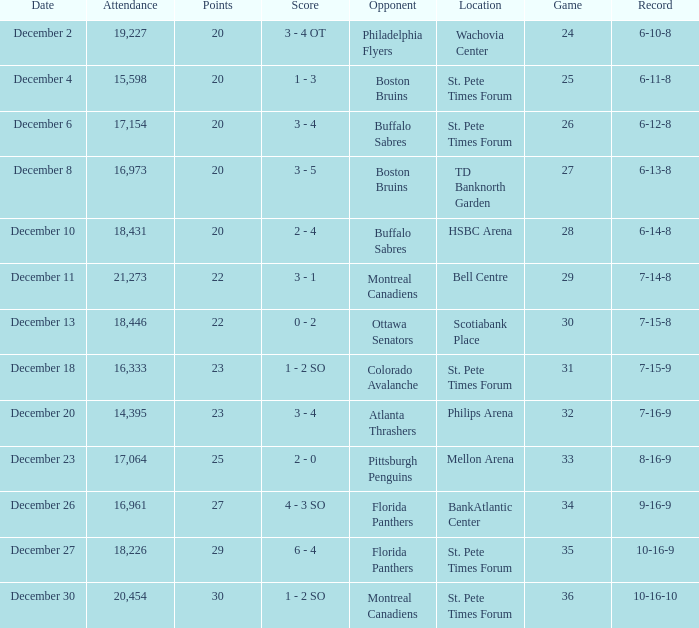Write the full table. {'header': ['Date', 'Attendance', 'Points', 'Score', 'Opponent', 'Location', 'Game', 'Record'], 'rows': [['December 2', '19,227', '20', '3 - 4 OT', 'Philadelphia Flyers', 'Wachovia Center', '24', '6-10-8'], ['December 4', '15,598', '20', '1 - 3', 'Boston Bruins', 'St. Pete Times Forum', '25', '6-11-8'], ['December 6', '17,154', '20', '3 - 4', 'Buffalo Sabres', 'St. Pete Times Forum', '26', '6-12-8'], ['December 8', '16,973', '20', '3 - 5', 'Boston Bruins', 'TD Banknorth Garden', '27', '6-13-8'], ['December 10', '18,431', '20', '2 - 4', 'Buffalo Sabres', 'HSBC Arena', '28', '6-14-8'], ['December 11', '21,273', '22', '3 - 1', 'Montreal Canadiens', 'Bell Centre', '29', '7-14-8'], ['December 13', '18,446', '22', '0 - 2', 'Ottawa Senators', 'Scotiabank Place', '30', '7-15-8'], ['December 18', '16,333', '23', '1 - 2 SO', 'Colorado Avalanche', 'St. Pete Times Forum', '31', '7-15-9'], ['December 20', '14,395', '23', '3 - 4', 'Atlanta Thrashers', 'Philips Arena', '32', '7-16-9'], ['December 23', '17,064', '25', '2 - 0', 'Pittsburgh Penguins', 'Mellon Arena', '33', '8-16-9'], ['December 26', '16,961', '27', '4 - 3 SO', 'Florida Panthers', 'BankAtlantic Center', '34', '9-16-9'], ['December 27', '18,226', '29', '6 - 4', 'Florida Panthers', 'St. Pete Times Forum', '35', '10-16-9'], ['December 30', '20,454', '30', '1 - 2 SO', 'Montreal Canadiens', 'St. Pete Times Forum', '36', '10-16-10']]} What is the location of the game with a 6-11-8 record? St. Pete Times Forum. 